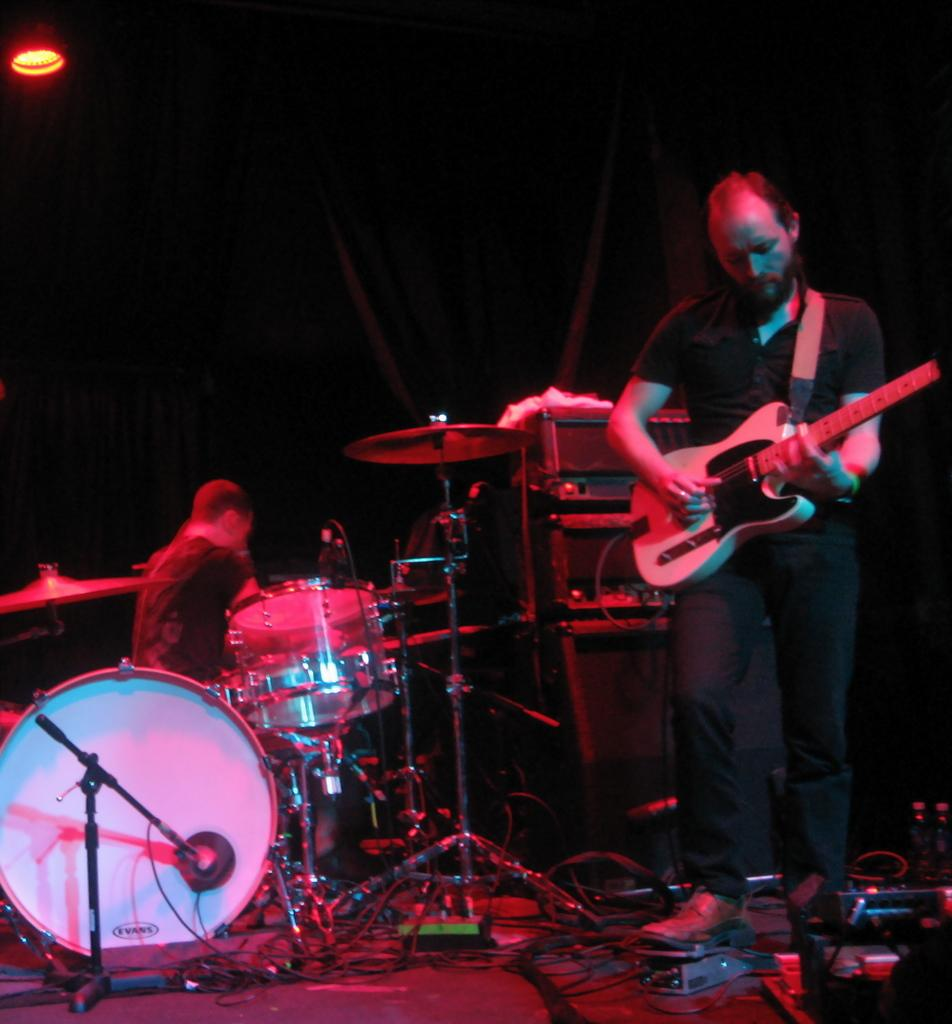What is the main subject of the image? There is a man in the image. What is the man wearing? The man is wearing a black shirt and black pants. What is the man holding in the image? The man is holding a musical instrument. Are there any other musical instruments visible in the image? Yes, there are other musical instruments visible in the image. What can be seen in the background of the image? There is a lamp and a black back curtain in the image. Can you tell me how many times the man sneezes in the image? There is no indication of the man sneezing in the image. What type of corn is growing on the roof in the image? There is no corn or roof present in the image. 